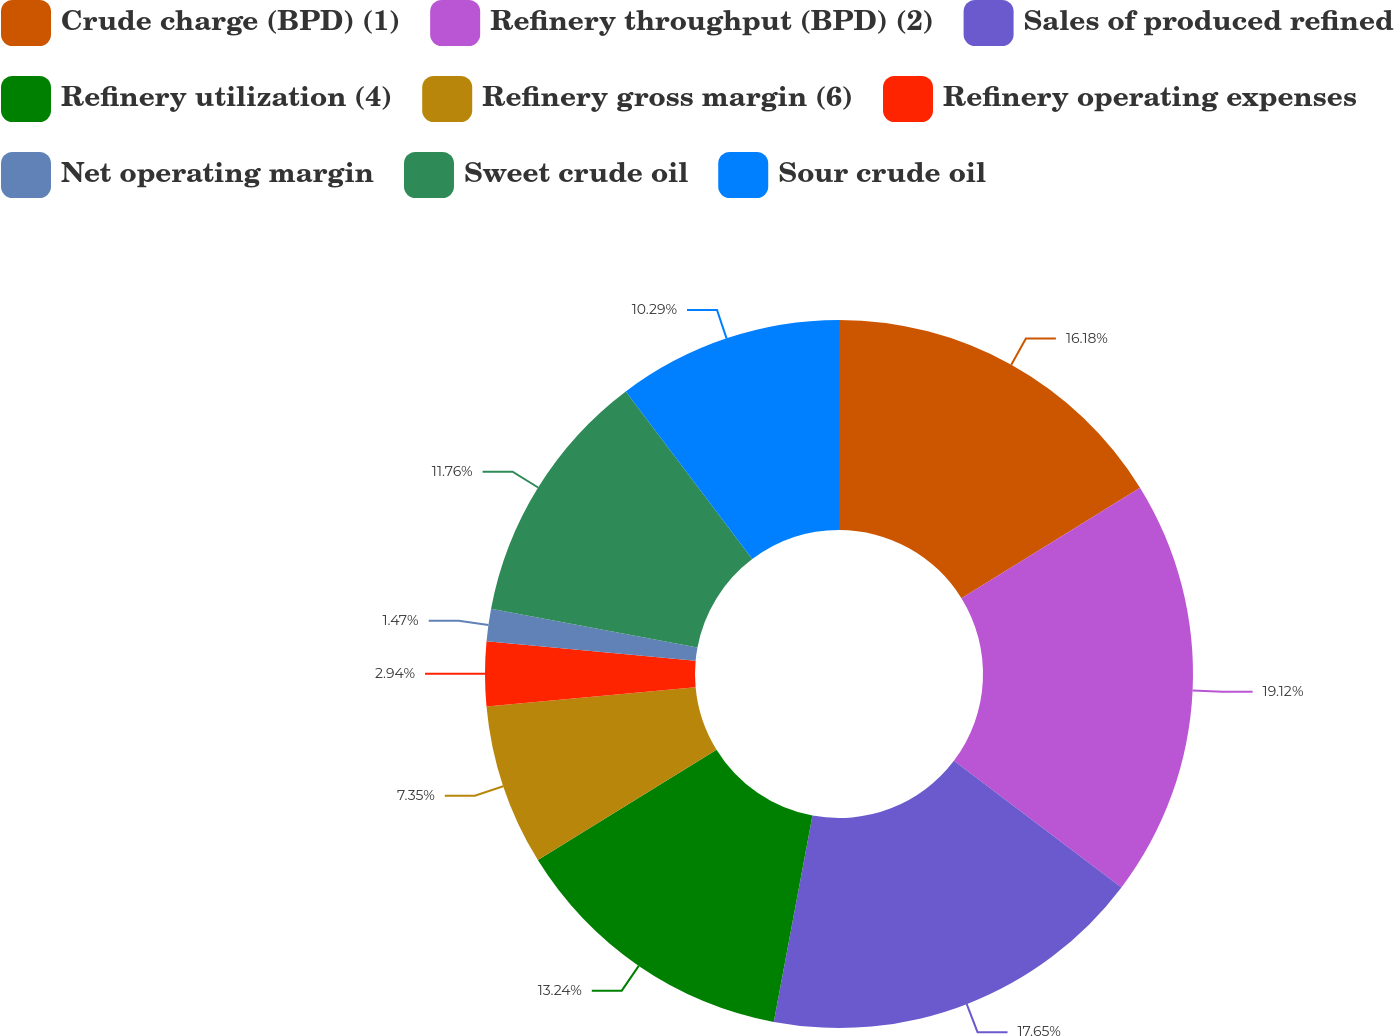Convert chart. <chart><loc_0><loc_0><loc_500><loc_500><pie_chart><fcel>Crude charge (BPD) (1)<fcel>Refinery throughput (BPD) (2)<fcel>Sales of produced refined<fcel>Refinery utilization (4)<fcel>Refinery gross margin (6)<fcel>Refinery operating expenses<fcel>Net operating margin<fcel>Sweet crude oil<fcel>Sour crude oil<nl><fcel>16.18%<fcel>19.12%<fcel>17.65%<fcel>13.24%<fcel>7.35%<fcel>2.94%<fcel>1.47%<fcel>11.76%<fcel>10.29%<nl></chart> 